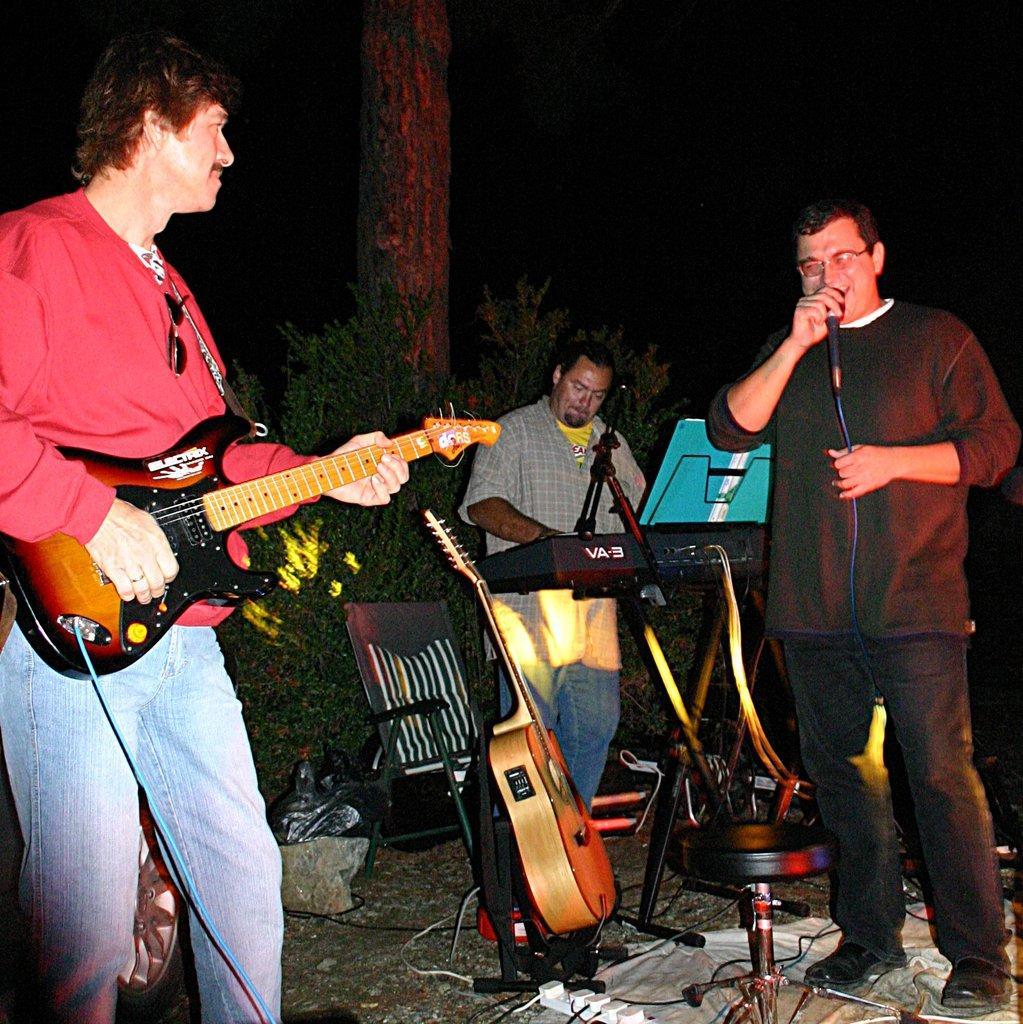How would you summarize this image in a sentence or two? In this picture there are people those who are playing the music, the person who is standing at the right side of the image he is singing in the mic and the person who is standing at the left side of the image he is playing the guitar an the person who is standing at the center of the image he is playing the piano, it is night time and there are some trees around the area. 